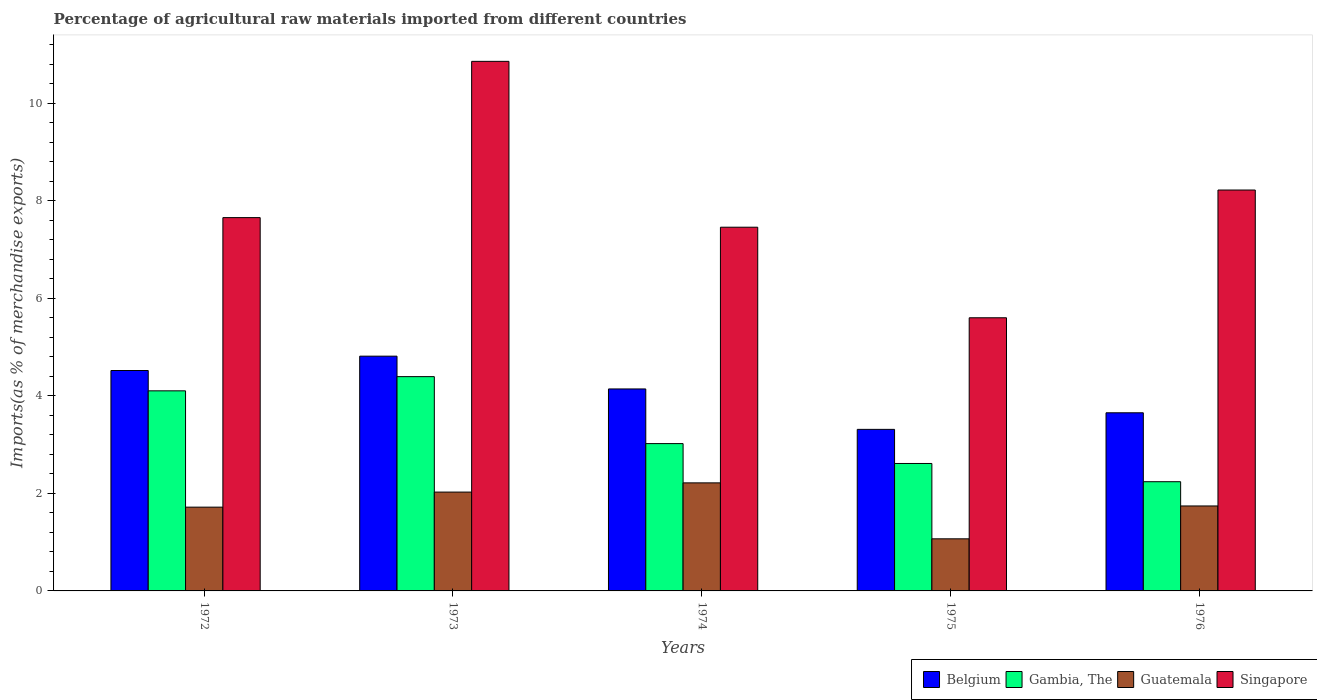How many groups of bars are there?
Make the answer very short. 5. Are the number of bars per tick equal to the number of legend labels?
Your answer should be compact. Yes. In how many cases, is the number of bars for a given year not equal to the number of legend labels?
Offer a very short reply. 0. What is the percentage of imports to different countries in Singapore in 1972?
Ensure brevity in your answer.  7.66. Across all years, what is the maximum percentage of imports to different countries in Guatemala?
Provide a short and direct response. 2.22. Across all years, what is the minimum percentage of imports to different countries in Singapore?
Give a very brief answer. 5.6. In which year was the percentage of imports to different countries in Guatemala maximum?
Your response must be concise. 1974. In which year was the percentage of imports to different countries in Belgium minimum?
Make the answer very short. 1975. What is the total percentage of imports to different countries in Guatemala in the graph?
Ensure brevity in your answer.  8.77. What is the difference between the percentage of imports to different countries in Singapore in 1972 and that in 1973?
Your response must be concise. -3.21. What is the difference between the percentage of imports to different countries in Gambia, The in 1975 and the percentage of imports to different countries in Guatemala in 1974?
Provide a short and direct response. 0.4. What is the average percentage of imports to different countries in Belgium per year?
Provide a short and direct response. 4.09. In the year 1973, what is the difference between the percentage of imports to different countries in Gambia, The and percentage of imports to different countries in Singapore?
Provide a succinct answer. -6.47. In how many years, is the percentage of imports to different countries in Belgium greater than 9.2 %?
Ensure brevity in your answer.  0. What is the ratio of the percentage of imports to different countries in Singapore in 1973 to that in 1976?
Your answer should be compact. 1.32. Is the difference between the percentage of imports to different countries in Gambia, The in 1972 and 1975 greater than the difference between the percentage of imports to different countries in Singapore in 1972 and 1975?
Offer a very short reply. No. What is the difference between the highest and the second highest percentage of imports to different countries in Belgium?
Your answer should be compact. 0.29. What is the difference between the highest and the lowest percentage of imports to different countries in Guatemala?
Provide a short and direct response. 1.15. In how many years, is the percentage of imports to different countries in Gambia, The greater than the average percentage of imports to different countries in Gambia, The taken over all years?
Make the answer very short. 2. Is the sum of the percentage of imports to different countries in Belgium in 1974 and 1976 greater than the maximum percentage of imports to different countries in Gambia, The across all years?
Keep it short and to the point. Yes. What does the 4th bar from the right in 1972 represents?
Give a very brief answer. Belgium. How many bars are there?
Give a very brief answer. 20. What is the difference between two consecutive major ticks on the Y-axis?
Provide a short and direct response. 2. Are the values on the major ticks of Y-axis written in scientific E-notation?
Ensure brevity in your answer.  No. Does the graph contain any zero values?
Your answer should be compact. No. How many legend labels are there?
Offer a very short reply. 4. What is the title of the graph?
Your answer should be very brief. Percentage of agricultural raw materials imported from different countries. Does "Cambodia" appear as one of the legend labels in the graph?
Offer a very short reply. No. What is the label or title of the Y-axis?
Your answer should be very brief. Imports(as % of merchandise exports). What is the Imports(as % of merchandise exports) in Belgium in 1972?
Make the answer very short. 4.52. What is the Imports(as % of merchandise exports) of Gambia, The in 1972?
Ensure brevity in your answer.  4.1. What is the Imports(as % of merchandise exports) in Guatemala in 1972?
Give a very brief answer. 1.72. What is the Imports(as % of merchandise exports) of Singapore in 1972?
Provide a short and direct response. 7.66. What is the Imports(as % of merchandise exports) of Belgium in 1973?
Your response must be concise. 4.82. What is the Imports(as % of merchandise exports) in Gambia, The in 1973?
Your answer should be compact. 4.4. What is the Imports(as % of merchandise exports) in Guatemala in 1973?
Ensure brevity in your answer.  2.03. What is the Imports(as % of merchandise exports) of Singapore in 1973?
Give a very brief answer. 10.86. What is the Imports(as % of merchandise exports) in Belgium in 1974?
Provide a short and direct response. 4.14. What is the Imports(as % of merchandise exports) in Gambia, The in 1974?
Make the answer very short. 3.02. What is the Imports(as % of merchandise exports) in Guatemala in 1974?
Provide a short and direct response. 2.22. What is the Imports(as % of merchandise exports) of Singapore in 1974?
Your response must be concise. 7.46. What is the Imports(as % of merchandise exports) in Belgium in 1975?
Provide a short and direct response. 3.31. What is the Imports(as % of merchandise exports) of Gambia, The in 1975?
Ensure brevity in your answer.  2.61. What is the Imports(as % of merchandise exports) of Guatemala in 1975?
Offer a very short reply. 1.07. What is the Imports(as % of merchandise exports) of Singapore in 1975?
Give a very brief answer. 5.6. What is the Imports(as % of merchandise exports) of Belgium in 1976?
Provide a short and direct response. 3.65. What is the Imports(as % of merchandise exports) of Gambia, The in 1976?
Your answer should be compact. 2.24. What is the Imports(as % of merchandise exports) in Guatemala in 1976?
Keep it short and to the point. 1.74. What is the Imports(as % of merchandise exports) of Singapore in 1976?
Your answer should be compact. 8.22. Across all years, what is the maximum Imports(as % of merchandise exports) in Belgium?
Keep it short and to the point. 4.82. Across all years, what is the maximum Imports(as % of merchandise exports) of Gambia, The?
Provide a short and direct response. 4.4. Across all years, what is the maximum Imports(as % of merchandise exports) of Guatemala?
Keep it short and to the point. 2.22. Across all years, what is the maximum Imports(as % of merchandise exports) of Singapore?
Keep it short and to the point. 10.86. Across all years, what is the minimum Imports(as % of merchandise exports) in Belgium?
Ensure brevity in your answer.  3.31. Across all years, what is the minimum Imports(as % of merchandise exports) in Gambia, The?
Provide a short and direct response. 2.24. Across all years, what is the minimum Imports(as % of merchandise exports) in Guatemala?
Your response must be concise. 1.07. Across all years, what is the minimum Imports(as % of merchandise exports) of Singapore?
Your answer should be compact. 5.6. What is the total Imports(as % of merchandise exports) in Belgium in the graph?
Your answer should be very brief. 20.45. What is the total Imports(as % of merchandise exports) of Gambia, The in the graph?
Provide a succinct answer. 16.38. What is the total Imports(as % of merchandise exports) of Guatemala in the graph?
Offer a terse response. 8.77. What is the total Imports(as % of merchandise exports) in Singapore in the graph?
Ensure brevity in your answer.  39.81. What is the difference between the Imports(as % of merchandise exports) of Belgium in 1972 and that in 1973?
Ensure brevity in your answer.  -0.29. What is the difference between the Imports(as % of merchandise exports) in Gambia, The in 1972 and that in 1973?
Provide a short and direct response. -0.29. What is the difference between the Imports(as % of merchandise exports) in Guatemala in 1972 and that in 1973?
Your answer should be very brief. -0.31. What is the difference between the Imports(as % of merchandise exports) of Singapore in 1972 and that in 1973?
Your answer should be compact. -3.21. What is the difference between the Imports(as % of merchandise exports) of Belgium in 1972 and that in 1974?
Provide a succinct answer. 0.38. What is the difference between the Imports(as % of merchandise exports) of Gambia, The in 1972 and that in 1974?
Make the answer very short. 1.08. What is the difference between the Imports(as % of merchandise exports) of Guatemala in 1972 and that in 1974?
Give a very brief answer. -0.5. What is the difference between the Imports(as % of merchandise exports) in Singapore in 1972 and that in 1974?
Offer a very short reply. 0.2. What is the difference between the Imports(as % of merchandise exports) in Belgium in 1972 and that in 1975?
Provide a succinct answer. 1.21. What is the difference between the Imports(as % of merchandise exports) of Gambia, The in 1972 and that in 1975?
Give a very brief answer. 1.49. What is the difference between the Imports(as % of merchandise exports) in Guatemala in 1972 and that in 1975?
Give a very brief answer. 0.65. What is the difference between the Imports(as % of merchandise exports) of Singapore in 1972 and that in 1975?
Ensure brevity in your answer.  2.05. What is the difference between the Imports(as % of merchandise exports) of Belgium in 1972 and that in 1976?
Ensure brevity in your answer.  0.87. What is the difference between the Imports(as % of merchandise exports) in Gambia, The in 1972 and that in 1976?
Provide a short and direct response. 1.86. What is the difference between the Imports(as % of merchandise exports) in Guatemala in 1972 and that in 1976?
Offer a very short reply. -0.02. What is the difference between the Imports(as % of merchandise exports) in Singapore in 1972 and that in 1976?
Offer a very short reply. -0.57. What is the difference between the Imports(as % of merchandise exports) of Belgium in 1973 and that in 1974?
Offer a very short reply. 0.67. What is the difference between the Imports(as % of merchandise exports) in Gambia, The in 1973 and that in 1974?
Provide a short and direct response. 1.37. What is the difference between the Imports(as % of merchandise exports) of Guatemala in 1973 and that in 1974?
Make the answer very short. -0.19. What is the difference between the Imports(as % of merchandise exports) of Singapore in 1973 and that in 1974?
Keep it short and to the point. 3.4. What is the difference between the Imports(as % of merchandise exports) of Belgium in 1973 and that in 1975?
Give a very brief answer. 1.5. What is the difference between the Imports(as % of merchandise exports) in Gambia, The in 1973 and that in 1975?
Ensure brevity in your answer.  1.78. What is the difference between the Imports(as % of merchandise exports) in Guatemala in 1973 and that in 1975?
Your answer should be compact. 0.96. What is the difference between the Imports(as % of merchandise exports) of Singapore in 1973 and that in 1975?
Your response must be concise. 5.26. What is the difference between the Imports(as % of merchandise exports) of Belgium in 1973 and that in 1976?
Ensure brevity in your answer.  1.16. What is the difference between the Imports(as % of merchandise exports) in Gambia, The in 1973 and that in 1976?
Your answer should be compact. 2.16. What is the difference between the Imports(as % of merchandise exports) of Guatemala in 1973 and that in 1976?
Offer a terse response. 0.28. What is the difference between the Imports(as % of merchandise exports) in Singapore in 1973 and that in 1976?
Provide a short and direct response. 2.64. What is the difference between the Imports(as % of merchandise exports) in Belgium in 1974 and that in 1975?
Provide a short and direct response. 0.83. What is the difference between the Imports(as % of merchandise exports) of Gambia, The in 1974 and that in 1975?
Offer a very short reply. 0.41. What is the difference between the Imports(as % of merchandise exports) in Guatemala in 1974 and that in 1975?
Your response must be concise. 1.15. What is the difference between the Imports(as % of merchandise exports) of Singapore in 1974 and that in 1975?
Offer a very short reply. 1.86. What is the difference between the Imports(as % of merchandise exports) of Belgium in 1974 and that in 1976?
Keep it short and to the point. 0.49. What is the difference between the Imports(as % of merchandise exports) of Gambia, The in 1974 and that in 1976?
Provide a short and direct response. 0.78. What is the difference between the Imports(as % of merchandise exports) of Guatemala in 1974 and that in 1976?
Ensure brevity in your answer.  0.47. What is the difference between the Imports(as % of merchandise exports) of Singapore in 1974 and that in 1976?
Give a very brief answer. -0.76. What is the difference between the Imports(as % of merchandise exports) in Belgium in 1975 and that in 1976?
Provide a succinct answer. -0.34. What is the difference between the Imports(as % of merchandise exports) of Gambia, The in 1975 and that in 1976?
Ensure brevity in your answer.  0.37. What is the difference between the Imports(as % of merchandise exports) in Guatemala in 1975 and that in 1976?
Provide a short and direct response. -0.67. What is the difference between the Imports(as % of merchandise exports) of Singapore in 1975 and that in 1976?
Provide a short and direct response. -2.62. What is the difference between the Imports(as % of merchandise exports) in Belgium in 1972 and the Imports(as % of merchandise exports) in Gambia, The in 1973?
Offer a very short reply. 0.13. What is the difference between the Imports(as % of merchandise exports) in Belgium in 1972 and the Imports(as % of merchandise exports) in Guatemala in 1973?
Your answer should be very brief. 2.49. What is the difference between the Imports(as % of merchandise exports) in Belgium in 1972 and the Imports(as % of merchandise exports) in Singapore in 1973?
Provide a short and direct response. -6.34. What is the difference between the Imports(as % of merchandise exports) in Gambia, The in 1972 and the Imports(as % of merchandise exports) in Guatemala in 1973?
Make the answer very short. 2.08. What is the difference between the Imports(as % of merchandise exports) in Gambia, The in 1972 and the Imports(as % of merchandise exports) in Singapore in 1973?
Make the answer very short. -6.76. What is the difference between the Imports(as % of merchandise exports) of Guatemala in 1972 and the Imports(as % of merchandise exports) of Singapore in 1973?
Ensure brevity in your answer.  -9.14. What is the difference between the Imports(as % of merchandise exports) in Belgium in 1972 and the Imports(as % of merchandise exports) in Gambia, The in 1974?
Provide a short and direct response. 1.5. What is the difference between the Imports(as % of merchandise exports) of Belgium in 1972 and the Imports(as % of merchandise exports) of Guatemala in 1974?
Ensure brevity in your answer.  2.31. What is the difference between the Imports(as % of merchandise exports) in Belgium in 1972 and the Imports(as % of merchandise exports) in Singapore in 1974?
Your answer should be very brief. -2.94. What is the difference between the Imports(as % of merchandise exports) in Gambia, The in 1972 and the Imports(as % of merchandise exports) in Guatemala in 1974?
Your answer should be very brief. 1.89. What is the difference between the Imports(as % of merchandise exports) of Gambia, The in 1972 and the Imports(as % of merchandise exports) of Singapore in 1974?
Your answer should be compact. -3.36. What is the difference between the Imports(as % of merchandise exports) in Guatemala in 1972 and the Imports(as % of merchandise exports) in Singapore in 1974?
Give a very brief answer. -5.74. What is the difference between the Imports(as % of merchandise exports) of Belgium in 1972 and the Imports(as % of merchandise exports) of Gambia, The in 1975?
Your answer should be very brief. 1.91. What is the difference between the Imports(as % of merchandise exports) of Belgium in 1972 and the Imports(as % of merchandise exports) of Guatemala in 1975?
Give a very brief answer. 3.45. What is the difference between the Imports(as % of merchandise exports) of Belgium in 1972 and the Imports(as % of merchandise exports) of Singapore in 1975?
Your answer should be very brief. -1.08. What is the difference between the Imports(as % of merchandise exports) in Gambia, The in 1972 and the Imports(as % of merchandise exports) in Guatemala in 1975?
Make the answer very short. 3.04. What is the difference between the Imports(as % of merchandise exports) in Gambia, The in 1972 and the Imports(as % of merchandise exports) in Singapore in 1975?
Make the answer very short. -1.5. What is the difference between the Imports(as % of merchandise exports) of Guatemala in 1972 and the Imports(as % of merchandise exports) of Singapore in 1975?
Offer a very short reply. -3.88. What is the difference between the Imports(as % of merchandise exports) in Belgium in 1972 and the Imports(as % of merchandise exports) in Gambia, The in 1976?
Give a very brief answer. 2.28. What is the difference between the Imports(as % of merchandise exports) of Belgium in 1972 and the Imports(as % of merchandise exports) of Guatemala in 1976?
Offer a very short reply. 2.78. What is the difference between the Imports(as % of merchandise exports) in Belgium in 1972 and the Imports(as % of merchandise exports) in Singapore in 1976?
Ensure brevity in your answer.  -3.7. What is the difference between the Imports(as % of merchandise exports) of Gambia, The in 1972 and the Imports(as % of merchandise exports) of Guatemala in 1976?
Your response must be concise. 2.36. What is the difference between the Imports(as % of merchandise exports) of Gambia, The in 1972 and the Imports(as % of merchandise exports) of Singapore in 1976?
Keep it short and to the point. -4.12. What is the difference between the Imports(as % of merchandise exports) in Guatemala in 1972 and the Imports(as % of merchandise exports) in Singapore in 1976?
Provide a short and direct response. -6.5. What is the difference between the Imports(as % of merchandise exports) in Belgium in 1973 and the Imports(as % of merchandise exports) in Gambia, The in 1974?
Ensure brevity in your answer.  1.79. What is the difference between the Imports(as % of merchandise exports) in Belgium in 1973 and the Imports(as % of merchandise exports) in Guatemala in 1974?
Keep it short and to the point. 2.6. What is the difference between the Imports(as % of merchandise exports) of Belgium in 1973 and the Imports(as % of merchandise exports) of Singapore in 1974?
Offer a very short reply. -2.65. What is the difference between the Imports(as % of merchandise exports) in Gambia, The in 1973 and the Imports(as % of merchandise exports) in Guatemala in 1974?
Provide a succinct answer. 2.18. What is the difference between the Imports(as % of merchandise exports) of Gambia, The in 1973 and the Imports(as % of merchandise exports) of Singapore in 1974?
Your response must be concise. -3.07. What is the difference between the Imports(as % of merchandise exports) of Guatemala in 1973 and the Imports(as % of merchandise exports) of Singapore in 1974?
Provide a short and direct response. -5.43. What is the difference between the Imports(as % of merchandise exports) in Belgium in 1973 and the Imports(as % of merchandise exports) in Gambia, The in 1975?
Provide a succinct answer. 2.2. What is the difference between the Imports(as % of merchandise exports) in Belgium in 1973 and the Imports(as % of merchandise exports) in Guatemala in 1975?
Provide a short and direct response. 3.75. What is the difference between the Imports(as % of merchandise exports) of Belgium in 1973 and the Imports(as % of merchandise exports) of Singapore in 1975?
Ensure brevity in your answer.  -0.79. What is the difference between the Imports(as % of merchandise exports) in Gambia, The in 1973 and the Imports(as % of merchandise exports) in Guatemala in 1975?
Your response must be concise. 3.33. What is the difference between the Imports(as % of merchandise exports) in Gambia, The in 1973 and the Imports(as % of merchandise exports) in Singapore in 1975?
Give a very brief answer. -1.21. What is the difference between the Imports(as % of merchandise exports) in Guatemala in 1973 and the Imports(as % of merchandise exports) in Singapore in 1975?
Provide a short and direct response. -3.58. What is the difference between the Imports(as % of merchandise exports) in Belgium in 1973 and the Imports(as % of merchandise exports) in Gambia, The in 1976?
Your answer should be very brief. 2.58. What is the difference between the Imports(as % of merchandise exports) of Belgium in 1973 and the Imports(as % of merchandise exports) of Guatemala in 1976?
Provide a short and direct response. 3.07. What is the difference between the Imports(as % of merchandise exports) in Belgium in 1973 and the Imports(as % of merchandise exports) in Singapore in 1976?
Your answer should be very brief. -3.41. What is the difference between the Imports(as % of merchandise exports) in Gambia, The in 1973 and the Imports(as % of merchandise exports) in Guatemala in 1976?
Your answer should be very brief. 2.65. What is the difference between the Imports(as % of merchandise exports) of Gambia, The in 1973 and the Imports(as % of merchandise exports) of Singapore in 1976?
Provide a short and direct response. -3.83. What is the difference between the Imports(as % of merchandise exports) of Guatemala in 1973 and the Imports(as % of merchandise exports) of Singapore in 1976?
Give a very brief answer. -6.2. What is the difference between the Imports(as % of merchandise exports) in Belgium in 1974 and the Imports(as % of merchandise exports) in Gambia, The in 1975?
Provide a succinct answer. 1.53. What is the difference between the Imports(as % of merchandise exports) in Belgium in 1974 and the Imports(as % of merchandise exports) in Guatemala in 1975?
Your response must be concise. 3.07. What is the difference between the Imports(as % of merchandise exports) of Belgium in 1974 and the Imports(as % of merchandise exports) of Singapore in 1975?
Your response must be concise. -1.46. What is the difference between the Imports(as % of merchandise exports) of Gambia, The in 1974 and the Imports(as % of merchandise exports) of Guatemala in 1975?
Give a very brief answer. 1.95. What is the difference between the Imports(as % of merchandise exports) of Gambia, The in 1974 and the Imports(as % of merchandise exports) of Singapore in 1975?
Keep it short and to the point. -2.58. What is the difference between the Imports(as % of merchandise exports) of Guatemala in 1974 and the Imports(as % of merchandise exports) of Singapore in 1975?
Offer a very short reply. -3.39. What is the difference between the Imports(as % of merchandise exports) in Belgium in 1974 and the Imports(as % of merchandise exports) in Gambia, The in 1976?
Offer a very short reply. 1.9. What is the difference between the Imports(as % of merchandise exports) in Belgium in 1974 and the Imports(as % of merchandise exports) in Guatemala in 1976?
Provide a short and direct response. 2.4. What is the difference between the Imports(as % of merchandise exports) in Belgium in 1974 and the Imports(as % of merchandise exports) in Singapore in 1976?
Ensure brevity in your answer.  -4.08. What is the difference between the Imports(as % of merchandise exports) of Gambia, The in 1974 and the Imports(as % of merchandise exports) of Guatemala in 1976?
Ensure brevity in your answer.  1.28. What is the difference between the Imports(as % of merchandise exports) of Gambia, The in 1974 and the Imports(as % of merchandise exports) of Singapore in 1976?
Provide a succinct answer. -5.2. What is the difference between the Imports(as % of merchandise exports) in Guatemala in 1974 and the Imports(as % of merchandise exports) in Singapore in 1976?
Ensure brevity in your answer.  -6.01. What is the difference between the Imports(as % of merchandise exports) of Belgium in 1975 and the Imports(as % of merchandise exports) of Gambia, The in 1976?
Make the answer very short. 1.07. What is the difference between the Imports(as % of merchandise exports) of Belgium in 1975 and the Imports(as % of merchandise exports) of Guatemala in 1976?
Your answer should be compact. 1.57. What is the difference between the Imports(as % of merchandise exports) of Belgium in 1975 and the Imports(as % of merchandise exports) of Singapore in 1976?
Ensure brevity in your answer.  -4.91. What is the difference between the Imports(as % of merchandise exports) in Gambia, The in 1975 and the Imports(as % of merchandise exports) in Guatemala in 1976?
Give a very brief answer. 0.87. What is the difference between the Imports(as % of merchandise exports) of Gambia, The in 1975 and the Imports(as % of merchandise exports) of Singapore in 1976?
Your answer should be compact. -5.61. What is the difference between the Imports(as % of merchandise exports) of Guatemala in 1975 and the Imports(as % of merchandise exports) of Singapore in 1976?
Provide a short and direct response. -7.15. What is the average Imports(as % of merchandise exports) in Belgium per year?
Provide a succinct answer. 4.09. What is the average Imports(as % of merchandise exports) of Gambia, The per year?
Offer a terse response. 3.28. What is the average Imports(as % of merchandise exports) in Guatemala per year?
Your answer should be very brief. 1.75. What is the average Imports(as % of merchandise exports) in Singapore per year?
Make the answer very short. 7.96. In the year 1972, what is the difference between the Imports(as % of merchandise exports) of Belgium and Imports(as % of merchandise exports) of Gambia, The?
Offer a very short reply. 0.42. In the year 1972, what is the difference between the Imports(as % of merchandise exports) of Belgium and Imports(as % of merchandise exports) of Guatemala?
Give a very brief answer. 2.8. In the year 1972, what is the difference between the Imports(as % of merchandise exports) in Belgium and Imports(as % of merchandise exports) in Singapore?
Your response must be concise. -3.14. In the year 1972, what is the difference between the Imports(as % of merchandise exports) of Gambia, The and Imports(as % of merchandise exports) of Guatemala?
Give a very brief answer. 2.39. In the year 1972, what is the difference between the Imports(as % of merchandise exports) in Gambia, The and Imports(as % of merchandise exports) in Singapore?
Ensure brevity in your answer.  -3.55. In the year 1972, what is the difference between the Imports(as % of merchandise exports) of Guatemala and Imports(as % of merchandise exports) of Singapore?
Keep it short and to the point. -5.94. In the year 1973, what is the difference between the Imports(as % of merchandise exports) in Belgium and Imports(as % of merchandise exports) in Gambia, The?
Your answer should be compact. 0.42. In the year 1973, what is the difference between the Imports(as % of merchandise exports) in Belgium and Imports(as % of merchandise exports) in Guatemala?
Your answer should be compact. 2.79. In the year 1973, what is the difference between the Imports(as % of merchandise exports) of Belgium and Imports(as % of merchandise exports) of Singapore?
Your answer should be very brief. -6.05. In the year 1973, what is the difference between the Imports(as % of merchandise exports) in Gambia, The and Imports(as % of merchandise exports) in Guatemala?
Offer a very short reply. 2.37. In the year 1973, what is the difference between the Imports(as % of merchandise exports) of Gambia, The and Imports(as % of merchandise exports) of Singapore?
Give a very brief answer. -6.47. In the year 1973, what is the difference between the Imports(as % of merchandise exports) in Guatemala and Imports(as % of merchandise exports) in Singapore?
Make the answer very short. -8.84. In the year 1974, what is the difference between the Imports(as % of merchandise exports) of Belgium and Imports(as % of merchandise exports) of Gambia, The?
Offer a very short reply. 1.12. In the year 1974, what is the difference between the Imports(as % of merchandise exports) of Belgium and Imports(as % of merchandise exports) of Guatemala?
Your answer should be compact. 1.93. In the year 1974, what is the difference between the Imports(as % of merchandise exports) of Belgium and Imports(as % of merchandise exports) of Singapore?
Your answer should be very brief. -3.32. In the year 1974, what is the difference between the Imports(as % of merchandise exports) in Gambia, The and Imports(as % of merchandise exports) in Guatemala?
Offer a very short reply. 0.81. In the year 1974, what is the difference between the Imports(as % of merchandise exports) of Gambia, The and Imports(as % of merchandise exports) of Singapore?
Make the answer very short. -4.44. In the year 1974, what is the difference between the Imports(as % of merchandise exports) in Guatemala and Imports(as % of merchandise exports) in Singapore?
Your answer should be very brief. -5.24. In the year 1975, what is the difference between the Imports(as % of merchandise exports) of Belgium and Imports(as % of merchandise exports) of Gambia, The?
Offer a terse response. 0.7. In the year 1975, what is the difference between the Imports(as % of merchandise exports) of Belgium and Imports(as % of merchandise exports) of Guatemala?
Your answer should be compact. 2.25. In the year 1975, what is the difference between the Imports(as % of merchandise exports) in Belgium and Imports(as % of merchandise exports) in Singapore?
Provide a short and direct response. -2.29. In the year 1975, what is the difference between the Imports(as % of merchandise exports) of Gambia, The and Imports(as % of merchandise exports) of Guatemala?
Your response must be concise. 1.55. In the year 1975, what is the difference between the Imports(as % of merchandise exports) of Gambia, The and Imports(as % of merchandise exports) of Singapore?
Provide a succinct answer. -2.99. In the year 1975, what is the difference between the Imports(as % of merchandise exports) in Guatemala and Imports(as % of merchandise exports) in Singapore?
Make the answer very short. -4.53. In the year 1976, what is the difference between the Imports(as % of merchandise exports) in Belgium and Imports(as % of merchandise exports) in Gambia, The?
Provide a short and direct response. 1.41. In the year 1976, what is the difference between the Imports(as % of merchandise exports) in Belgium and Imports(as % of merchandise exports) in Guatemala?
Provide a succinct answer. 1.91. In the year 1976, what is the difference between the Imports(as % of merchandise exports) of Belgium and Imports(as % of merchandise exports) of Singapore?
Your response must be concise. -4.57. In the year 1976, what is the difference between the Imports(as % of merchandise exports) in Gambia, The and Imports(as % of merchandise exports) in Guatemala?
Your answer should be very brief. 0.5. In the year 1976, what is the difference between the Imports(as % of merchandise exports) of Gambia, The and Imports(as % of merchandise exports) of Singapore?
Your answer should be compact. -5.98. In the year 1976, what is the difference between the Imports(as % of merchandise exports) of Guatemala and Imports(as % of merchandise exports) of Singapore?
Provide a short and direct response. -6.48. What is the ratio of the Imports(as % of merchandise exports) of Belgium in 1972 to that in 1973?
Your answer should be compact. 0.94. What is the ratio of the Imports(as % of merchandise exports) of Gambia, The in 1972 to that in 1973?
Your response must be concise. 0.93. What is the ratio of the Imports(as % of merchandise exports) in Guatemala in 1972 to that in 1973?
Keep it short and to the point. 0.85. What is the ratio of the Imports(as % of merchandise exports) in Singapore in 1972 to that in 1973?
Your answer should be compact. 0.7. What is the ratio of the Imports(as % of merchandise exports) of Belgium in 1972 to that in 1974?
Offer a terse response. 1.09. What is the ratio of the Imports(as % of merchandise exports) of Gambia, The in 1972 to that in 1974?
Give a very brief answer. 1.36. What is the ratio of the Imports(as % of merchandise exports) of Guatemala in 1972 to that in 1974?
Your response must be concise. 0.78. What is the ratio of the Imports(as % of merchandise exports) in Singapore in 1972 to that in 1974?
Make the answer very short. 1.03. What is the ratio of the Imports(as % of merchandise exports) of Belgium in 1972 to that in 1975?
Your answer should be very brief. 1.36. What is the ratio of the Imports(as % of merchandise exports) in Gambia, The in 1972 to that in 1975?
Make the answer very short. 1.57. What is the ratio of the Imports(as % of merchandise exports) of Guatemala in 1972 to that in 1975?
Give a very brief answer. 1.61. What is the ratio of the Imports(as % of merchandise exports) in Singapore in 1972 to that in 1975?
Your response must be concise. 1.37. What is the ratio of the Imports(as % of merchandise exports) of Belgium in 1972 to that in 1976?
Give a very brief answer. 1.24. What is the ratio of the Imports(as % of merchandise exports) in Gambia, The in 1972 to that in 1976?
Ensure brevity in your answer.  1.83. What is the ratio of the Imports(as % of merchandise exports) in Singapore in 1972 to that in 1976?
Ensure brevity in your answer.  0.93. What is the ratio of the Imports(as % of merchandise exports) in Belgium in 1973 to that in 1974?
Offer a very short reply. 1.16. What is the ratio of the Imports(as % of merchandise exports) in Gambia, The in 1973 to that in 1974?
Ensure brevity in your answer.  1.45. What is the ratio of the Imports(as % of merchandise exports) of Guatemala in 1973 to that in 1974?
Offer a very short reply. 0.91. What is the ratio of the Imports(as % of merchandise exports) of Singapore in 1973 to that in 1974?
Offer a very short reply. 1.46. What is the ratio of the Imports(as % of merchandise exports) of Belgium in 1973 to that in 1975?
Ensure brevity in your answer.  1.45. What is the ratio of the Imports(as % of merchandise exports) in Gambia, The in 1973 to that in 1975?
Offer a very short reply. 1.68. What is the ratio of the Imports(as % of merchandise exports) in Guatemala in 1973 to that in 1975?
Your response must be concise. 1.9. What is the ratio of the Imports(as % of merchandise exports) of Singapore in 1973 to that in 1975?
Ensure brevity in your answer.  1.94. What is the ratio of the Imports(as % of merchandise exports) of Belgium in 1973 to that in 1976?
Provide a short and direct response. 1.32. What is the ratio of the Imports(as % of merchandise exports) of Gambia, The in 1973 to that in 1976?
Provide a succinct answer. 1.96. What is the ratio of the Imports(as % of merchandise exports) of Guatemala in 1973 to that in 1976?
Keep it short and to the point. 1.16. What is the ratio of the Imports(as % of merchandise exports) in Singapore in 1973 to that in 1976?
Keep it short and to the point. 1.32. What is the ratio of the Imports(as % of merchandise exports) in Belgium in 1974 to that in 1975?
Your response must be concise. 1.25. What is the ratio of the Imports(as % of merchandise exports) of Gambia, The in 1974 to that in 1975?
Offer a very short reply. 1.16. What is the ratio of the Imports(as % of merchandise exports) of Guatemala in 1974 to that in 1975?
Offer a terse response. 2.07. What is the ratio of the Imports(as % of merchandise exports) of Singapore in 1974 to that in 1975?
Provide a short and direct response. 1.33. What is the ratio of the Imports(as % of merchandise exports) of Belgium in 1974 to that in 1976?
Provide a short and direct response. 1.13. What is the ratio of the Imports(as % of merchandise exports) in Gambia, The in 1974 to that in 1976?
Your answer should be very brief. 1.35. What is the ratio of the Imports(as % of merchandise exports) of Guatemala in 1974 to that in 1976?
Provide a succinct answer. 1.27. What is the ratio of the Imports(as % of merchandise exports) of Singapore in 1974 to that in 1976?
Provide a short and direct response. 0.91. What is the ratio of the Imports(as % of merchandise exports) in Belgium in 1975 to that in 1976?
Provide a succinct answer. 0.91. What is the ratio of the Imports(as % of merchandise exports) of Gambia, The in 1975 to that in 1976?
Your response must be concise. 1.17. What is the ratio of the Imports(as % of merchandise exports) of Guatemala in 1975 to that in 1976?
Keep it short and to the point. 0.61. What is the ratio of the Imports(as % of merchandise exports) in Singapore in 1975 to that in 1976?
Ensure brevity in your answer.  0.68. What is the difference between the highest and the second highest Imports(as % of merchandise exports) in Belgium?
Make the answer very short. 0.29. What is the difference between the highest and the second highest Imports(as % of merchandise exports) of Gambia, The?
Your answer should be compact. 0.29. What is the difference between the highest and the second highest Imports(as % of merchandise exports) of Guatemala?
Your answer should be compact. 0.19. What is the difference between the highest and the second highest Imports(as % of merchandise exports) in Singapore?
Provide a short and direct response. 2.64. What is the difference between the highest and the lowest Imports(as % of merchandise exports) in Belgium?
Keep it short and to the point. 1.5. What is the difference between the highest and the lowest Imports(as % of merchandise exports) in Gambia, The?
Your response must be concise. 2.16. What is the difference between the highest and the lowest Imports(as % of merchandise exports) in Guatemala?
Provide a short and direct response. 1.15. What is the difference between the highest and the lowest Imports(as % of merchandise exports) in Singapore?
Your answer should be very brief. 5.26. 